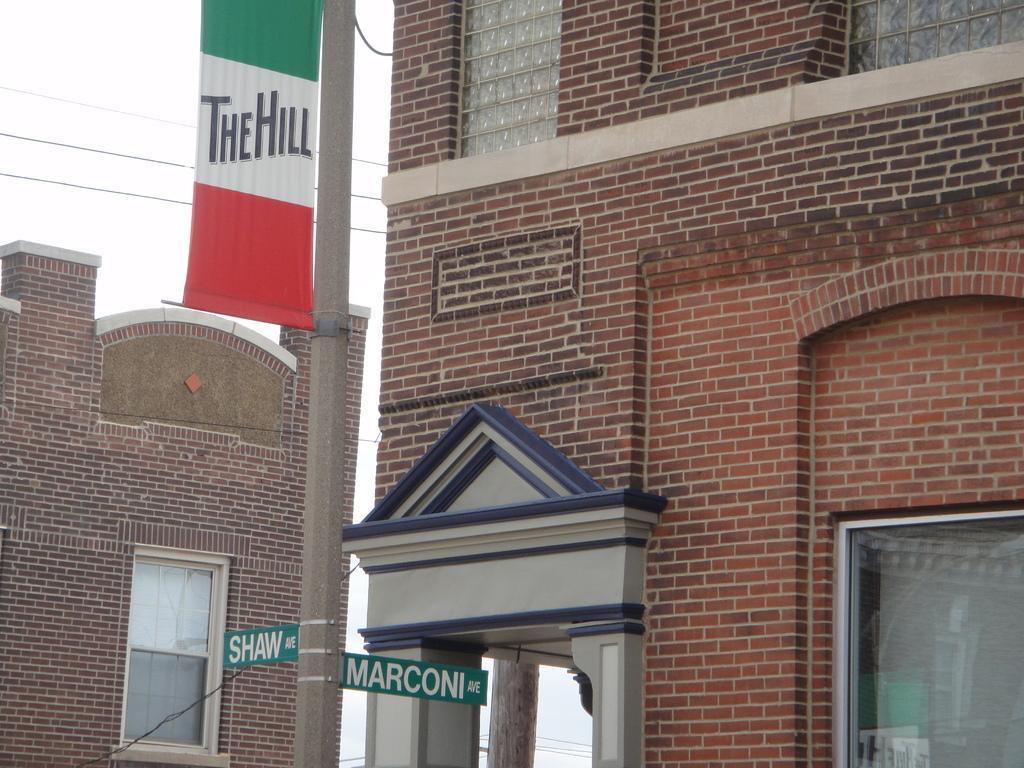In one or two sentences, can you explain what this image depicts? In this picture I can see buildings, cables, a banner and name boards to the pole , and in the background there is sky. 